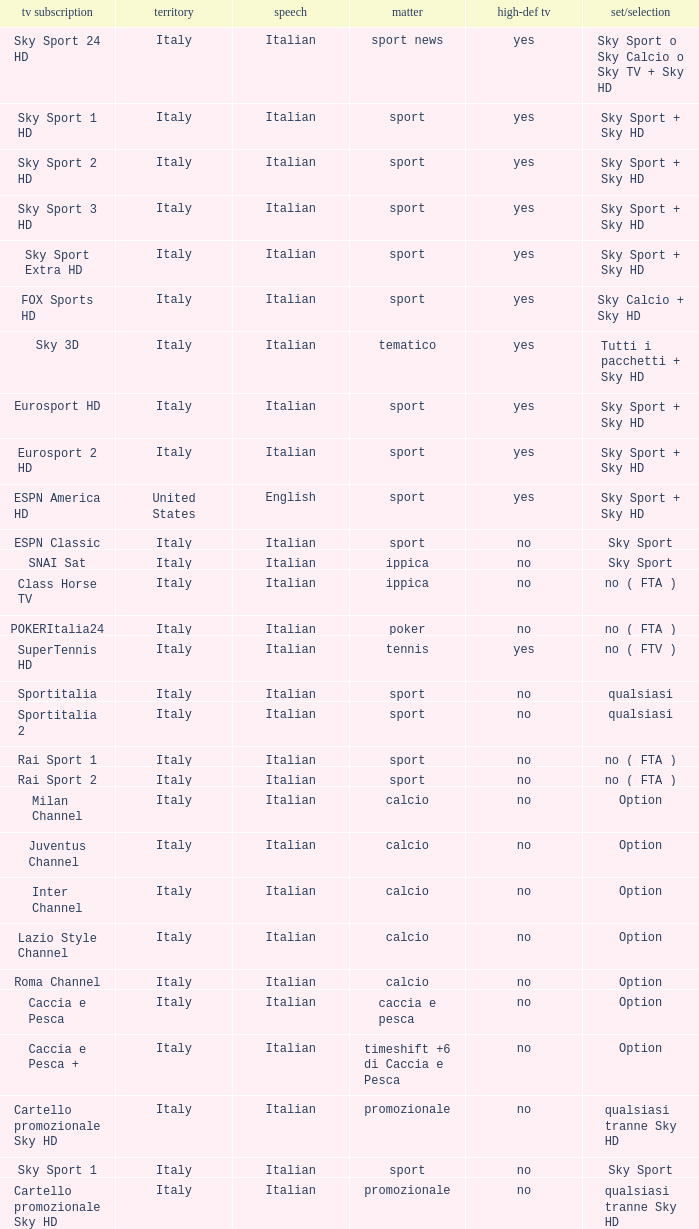What is Package/Option, when Content is Poker? No ( fta ). 